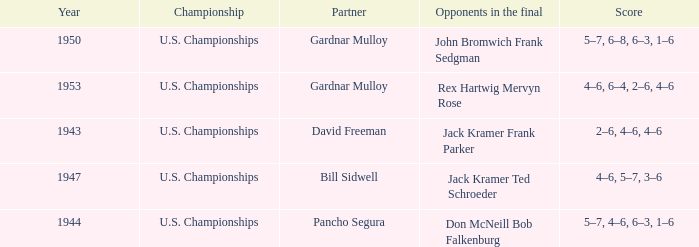Which Partner has Opponents in the final of john bromwich frank sedgman? Gardnar Mulloy. 